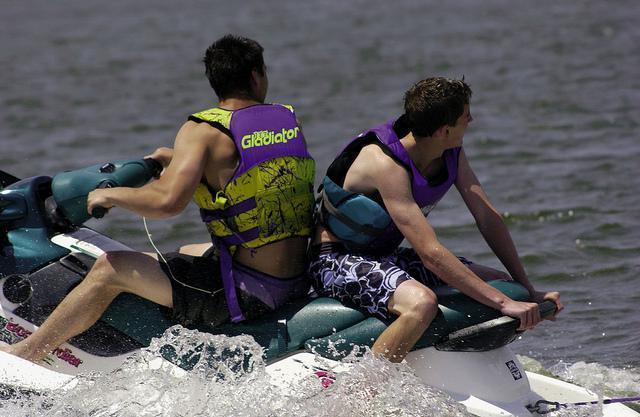How many people are in the photo?
Give a very brief answer. 2. 